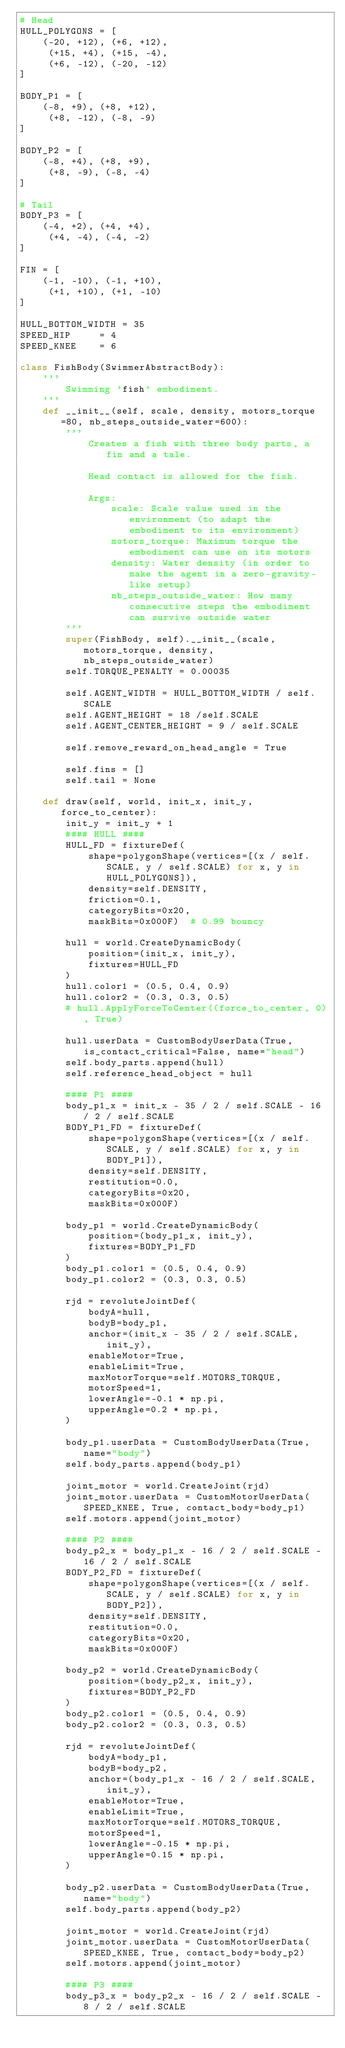<code> <loc_0><loc_0><loc_500><loc_500><_Python_># Head
HULL_POLYGONS = [
    (-20, +12), (+6, +12),
     (+15, +4), (+15, -4),
     (+6, -12), (-20, -12)
]

BODY_P1 = [
    (-8, +9), (+8, +12),
     (+8, -12), (-8, -9)
]

BODY_P2 = [
    (-8, +4), (+8, +9),
     (+8, -9), (-8, -4)
]

# Tail
BODY_P3 = [
    (-4, +2), (+4, +4),
     (+4, -4), (-4, -2)
]

FIN = [
    (-1, -10), (-1, +10),
     (+1, +10), (+1, -10)
]

HULL_BOTTOM_WIDTH = 35
SPEED_HIP     = 4
SPEED_KNEE    = 6

class FishBody(SwimmerAbstractBody):
    '''
        Swimming 'fish' embodiment.
    '''
    def __init__(self, scale, density, motors_torque=80, nb_steps_outside_water=600):
        '''
            Creates a fish with three body parts, a fin and a tale.

            Head contact is allowed for the fish.

            Args:
                scale: Scale value used in the environment (to adapt the embodiment to its environment)
                motors_torque: Maximum torque the embodiment can use on its motors
                density: Water density (in order to make the agent in a zero-gravity-like setup)
                nb_steps_outside_water: How many consecutive steps the embodiment can survive outside water
        '''
        super(FishBody, self).__init__(scale, motors_torque, density, nb_steps_outside_water)
        self.TORQUE_PENALTY = 0.00035

        self.AGENT_WIDTH = HULL_BOTTOM_WIDTH / self.SCALE
        self.AGENT_HEIGHT = 18 /self.SCALE
        self.AGENT_CENTER_HEIGHT = 9 / self.SCALE

        self.remove_reward_on_head_angle = True

        self.fins = []
        self.tail = None

    def draw(self, world, init_x, init_y, force_to_center):
        init_y = init_y + 1
        #### HULL ####
        HULL_FD = fixtureDef(
            shape=polygonShape(vertices=[(x / self.SCALE, y / self.SCALE) for x, y in HULL_POLYGONS]),
            density=self.DENSITY,
            friction=0.1,
            categoryBits=0x20,
            maskBits=0x000F)  # 0.99 bouncy

        hull = world.CreateDynamicBody(
            position=(init_x, init_y),
            fixtures=HULL_FD
        )
        hull.color1 = (0.5, 0.4, 0.9)
        hull.color2 = (0.3, 0.3, 0.5)
        # hull.ApplyForceToCenter((force_to_center, 0), True)

        hull.userData = CustomBodyUserData(True, is_contact_critical=False, name="head")
        self.body_parts.append(hull)
        self.reference_head_object = hull

        #### P1 ####
        body_p1_x = init_x - 35 / 2 / self.SCALE - 16 / 2 / self.SCALE
        BODY_P1_FD = fixtureDef(
            shape=polygonShape(vertices=[(x / self.SCALE, y / self.SCALE) for x, y in BODY_P1]),
            density=self.DENSITY,
            restitution=0.0,
            categoryBits=0x20,
            maskBits=0x000F)

        body_p1 = world.CreateDynamicBody(
            position=(body_p1_x, init_y),
            fixtures=BODY_P1_FD
        )
        body_p1.color1 = (0.5, 0.4, 0.9)
        body_p1.color2 = (0.3, 0.3, 0.5)

        rjd = revoluteJointDef(
            bodyA=hull,
            bodyB=body_p1,
            anchor=(init_x - 35 / 2 / self.SCALE, init_y),
            enableMotor=True,
            enableLimit=True,
            maxMotorTorque=self.MOTORS_TORQUE,
            motorSpeed=1,
            lowerAngle=-0.1 * np.pi,
            upperAngle=0.2 * np.pi,
        )

        body_p1.userData = CustomBodyUserData(True, name="body")
        self.body_parts.append(body_p1)

        joint_motor = world.CreateJoint(rjd)
        joint_motor.userData = CustomMotorUserData(SPEED_KNEE, True, contact_body=body_p1)
        self.motors.append(joint_motor)

        #### P2 ####
        body_p2_x = body_p1_x - 16 / 2 / self.SCALE - 16 / 2 / self.SCALE
        BODY_P2_FD = fixtureDef(
            shape=polygonShape(vertices=[(x / self.SCALE, y / self.SCALE) for x, y in BODY_P2]),
            density=self.DENSITY,
            restitution=0.0,
            categoryBits=0x20,
            maskBits=0x000F)

        body_p2 = world.CreateDynamicBody(
            position=(body_p2_x, init_y),
            fixtures=BODY_P2_FD
        )
        body_p2.color1 = (0.5, 0.4, 0.9)
        body_p2.color2 = (0.3, 0.3, 0.5)

        rjd = revoluteJointDef(
            bodyA=body_p1,
            bodyB=body_p2,
            anchor=(body_p1_x - 16 / 2 / self.SCALE, init_y),
            enableMotor=True,
            enableLimit=True,
            maxMotorTorque=self.MOTORS_TORQUE,
            motorSpeed=1,
            lowerAngle=-0.15 * np.pi,
            upperAngle=0.15 * np.pi,
        )

        body_p2.userData = CustomBodyUserData(True, name="body")
        self.body_parts.append(body_p2)

        joint_motor = world.CreateJoint(rjd)
        joint_motor.userData = CustomMotorUserData(SPEED_KNEE, True, contact_body=body_p2)
        self.motors.append(joint_motor)

        #### P3 ####
        body_p3_x = body_p2_x - 16 / 2 / self.SCALE - 8 / 2 / self.SCALE</code> 